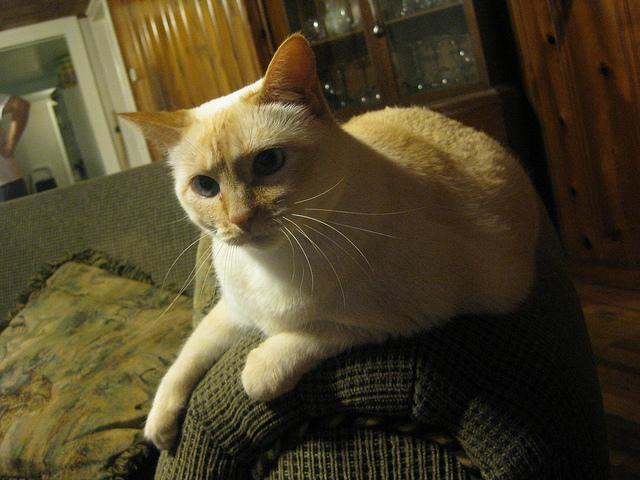How many cats are there?
Give a very brief answer. 1. How many of the bowls in the image contain mushrooms?
Give a very brief answer. 0. 